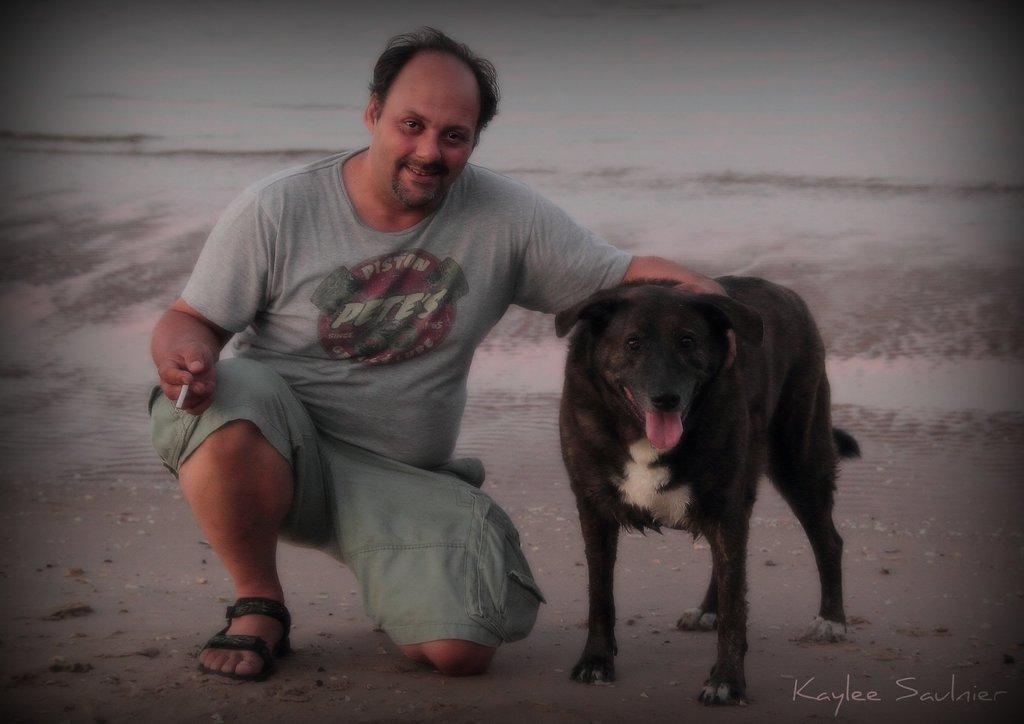Could you give a brief overview of what you see in this image? In this image there is a man in a squatting position. He is holding a cigar in one hand and putting another hand on a dog. He is wearing a grey t shirt, green shorts and black sandals. In the background there is a ocean. 